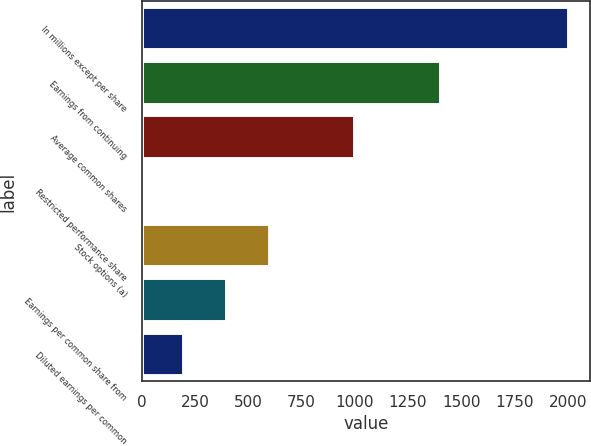<chart> <loc_0><loc_0><loc_500><loc_500><bar_chart><fcel>In millions except per share<fcel>Earnings from continuing<fcel>Average common shares<fcel>Restricted performance share<fcel>Stock options (a)<fcel>Earnings per common share from<fcel>Diluted earnings per common<nl><fcel>2005<fcel>1403.74<fcel>1002.9<fcel>0.8<fcel>602.06<fcel>401.64<fcel>201.22<nl></chart> 